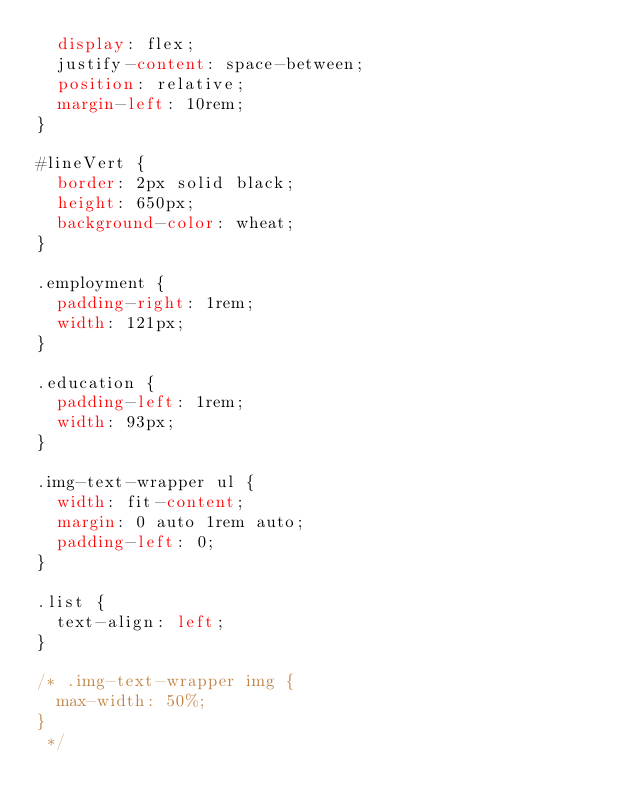Convert code to text. <code><loc_0><loc_0><loc_500><loc_500><_CSS_>  display: flex;
  justify-content: space-between;
  position: relative;
  margin-left: 10rem;
}

#lineVert {
  border: 2px solid black;
  height: 650px;
  background-color: wheat;
}

.employment {
  padding-right: 1rem;
  width: 121px;
}

.education {
  padding-left: 1rem;
  width: 93px;
}

.img-text-wrapper ul {
  width: fit-content;
  margin: 0 auto 1rem auto;
  padding-left: 0;
}

.list {
  text-align: left;
}

/* .img-text-wrapper img {
  max-width: 50%;
}
 */
</code> 